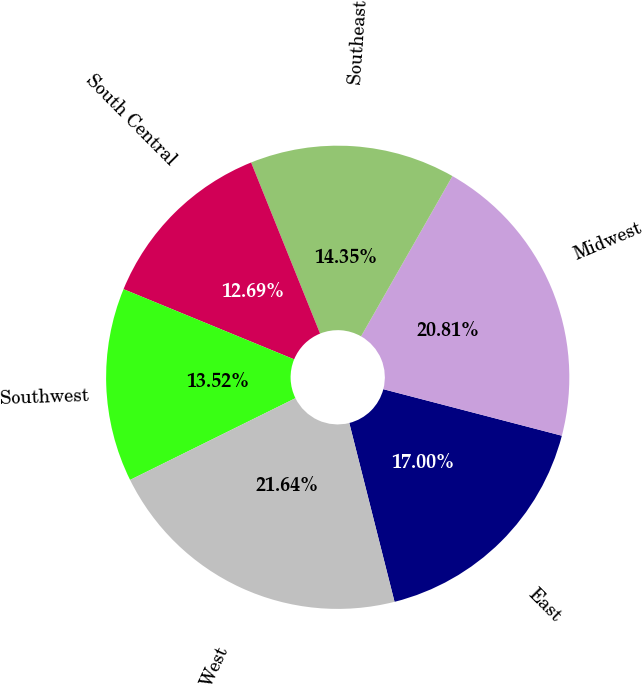Convert chart. <chart><loc_0><loc_0><loc_500><loc_500><pie_chart><fcel>East<fcel>Midwest<fcel>Southeast<fcel>South Central<fcel>Southwest<fcel>West<nl><fcel>17.0%<fcel>20.81%<fcel>14.35%<fcel>12.69%<fcel>13.52%<fcel>21.64%<nl></chart> 